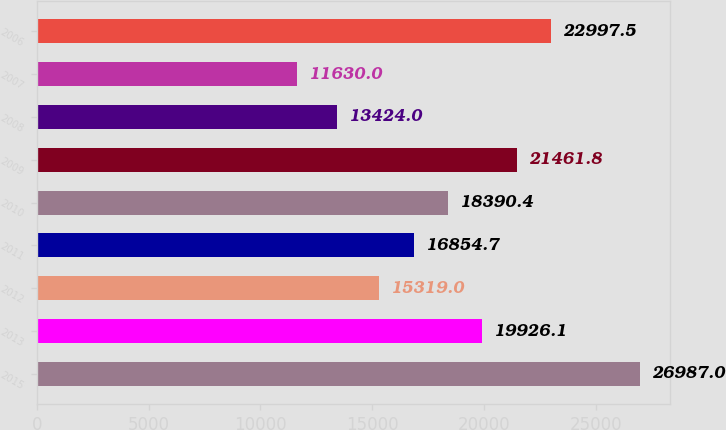<chart> <loc_0><loc_0><loc_500><loc_500><bar_chart><fcel>2015<fcel>2013<fcel>2012<fcel>2011<fcel>2010<fcel>2009<fcel>2008<fcel>2007<fcel>2006<nl><fcel>26987<fcel>19926.1<fcel>15319<fcel>16854.7<fcel>18390.4<fcel>21461.8<fcel>13424<fcel>11630<fcel>22997.5<nl></chart> 